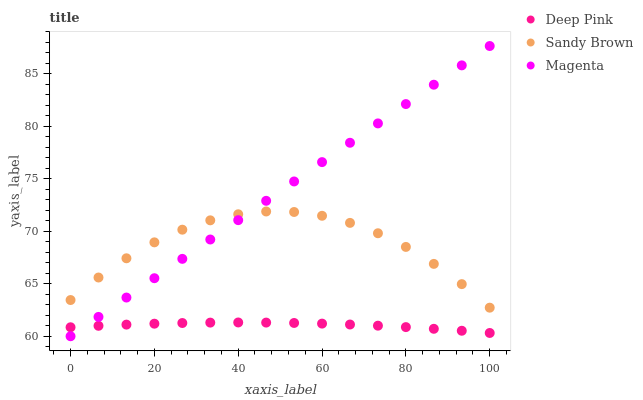Does Deep Pink have the minimum area under the curve?
Answer yes or no. Yes. Does Magenta have the maximum area under the curve?
Answer yes or no. Yes. Does Sandy Brown have the minimum area under the curve?
Answer yes or no. No. Does Sandy Brown have the maximum area under the curve?
Answer yes or no. No. Is Magenta the smoothest?
Answer yes or no. Yes. Is Sandy Brown the roughest?
Answer yes or no. Yes. Is Deep Pink the smoothest?
Answer yes or no. No. Is Deep Pink the roughest?
Answer yes or no. No. Does Magenta have the lowest value?
Answer yes or no. Yes. Does Deep Pink have the lowest value?
Answer yes or no. No. Does Magenta have the highest value?
Answer yes or no. Yes. Does Sandy Brown have the highest value?
Answer yes or no. No. Is Deep Pink less than Sandy Brown?
Answer yes or no. Yes. Is Sandy Brown greater than Deep Pink?
Answer yes or no. Yes. Does Magenta intersect Deep Pink?
Answer yes or no. Yes. Is Magenta less than Deep Pink?
Answer yes or no. No. Is Magenta greater than Deep Pink?
Answer yes or no. No. Does Deep Pink intersect Sandy Brown?
Answer yes or no. No. 